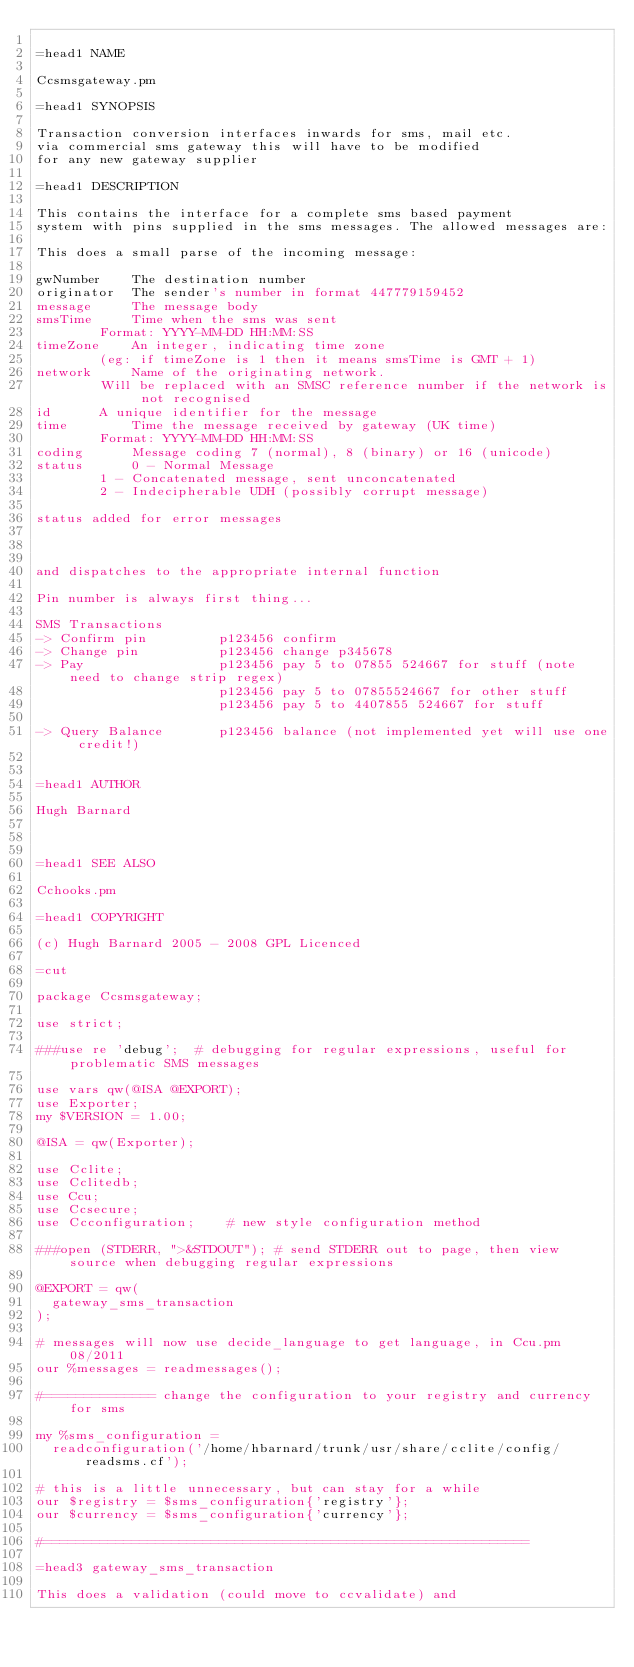Convert code to text. <code><loc_0><loc_0><loc_500><loc_500><_Perl_>
=head1 NAME

Ccsmsgateway.pm

=head1 SYNOPSIS

Transaction conversion interfaces inwards for sms, mail etc.
via commercial sms gateway this will have to be modified
for any new gateway supplier

=head1 DESCRIPTION

This contains the interface for a complete sms based payment
system with pins supplied in the sms messages. The allowed messages are:

This does a small parse of the incoming message:

gwNumber  	The destination number
originator 	The sender's number in format 447779159452
message 	The message body
smsTime 	Time when the sms was sent
		Format: YYYY-MM-DD HH:MM:SS
timeZone 	An integer, indicating time zone
		(eg: if timeZone is 1 then it means smsTime is GMT + 1)
network 	Name of the originating network.
		Will be replaced with an SMSC reference number if the network is not recognised
id 		A unique identifier for the message
time 		Time the message received by gateway (UK time)
		Format: YYYY-MM-DD HH:MM:SS
coding 		Message coding 7 (normal), 8 (binary) or 16 (unicode)
status 		0 - Normal Message
		1 - Concatenated message, sent unconcatenated
		2 - Indecipherable UDH (possibly corrupt message)

status added for error messages



and dispatches to the appropriate internal function

Pin number is always first thing...

SMS Transactions
-> Confirm pin         p123456 confirm-> Change pin          p123456 change p345678
-> Pay                 p123456 pay 5 to 07855 524667 for stuff (note need to change strip regex)
                       p123456 pay 5 to 07855524667 for other stuff
                       p123456 pay 5 to 4407855 524667 for stuff

-> Query Balance       p123456 balance (not implemented yet will use one credit!)


=head1 AUTHOR

Hugh Barnard



=head1 SEE ALSO

Cchooks.pm

=head1 COPYRIGHT

(c) Hugh Barnard 2005 - 2008 GPL Licenced
 
=cut

package Ccsmsgateway;

use strict;

###use re 'debug';  # debugging for regular expressions, useful for problematic SMS messages

use vars qw(@ISA @EXPORT);
use Exporter;
my $VERSION = 1.00;

@ISA = qw(Exporter);

use Cclite;
use Cclitedb;
use Ccu;
use Ccsecure;
use Ccconfiguration;    # new style configuration method

###open (STDERR, ">&STDOUT"); # send STDERR out to page, then view source when debugging regular expressions

@EXPORT = qw(
  gateway_sms_transaction
);

# messages will now use decide_language to get language, in Ccu.pm 08/2011
our %messages = readmessages();

#============== change the configuration to your registry and currency for sms

my %sms_configuration =
  readconfiguration('/home/hbarnard/trunk/usr/share/cclite/config/readsms.cf');

# this is a little unnecessary, but can stay for a while
our $registry = $sms_configuration{'registry'};
our $currency = $sms_configuration{'currency'};

#=============================================================

=head3 gateway_sms_transaction

This does a validation (could move to ccvalidate) and</code> 